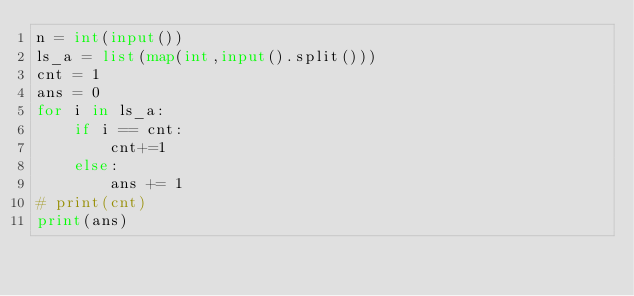<code> <loc_0><loc_0><loc_500><loc_500><_Python_>n = int(input())
ls_a = list(map(int,input().split()))
cnt = 1
ans = 0
for i in ls_a:
    if i == cnt:
        cnt+=1
    else:
        ans += 1
# print(cnt)
print(ans)</code> 